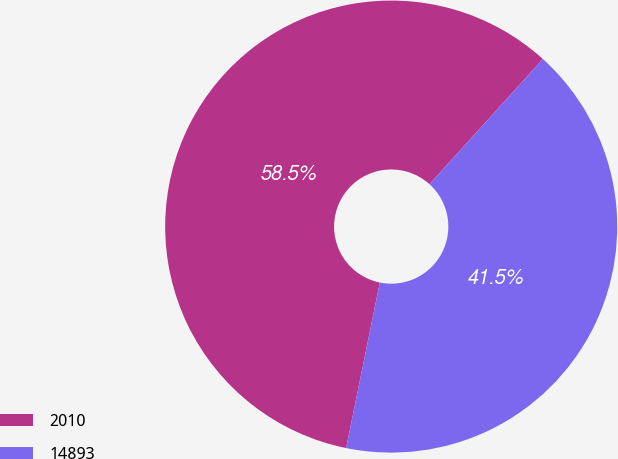Convert chart. <chart><loc_0><loc_0><loc_500><loc_500><pie_chart><fcel>2010<fcel>14893<nl><fcel>58.51%<fcel>41.49%<nl></chart> 